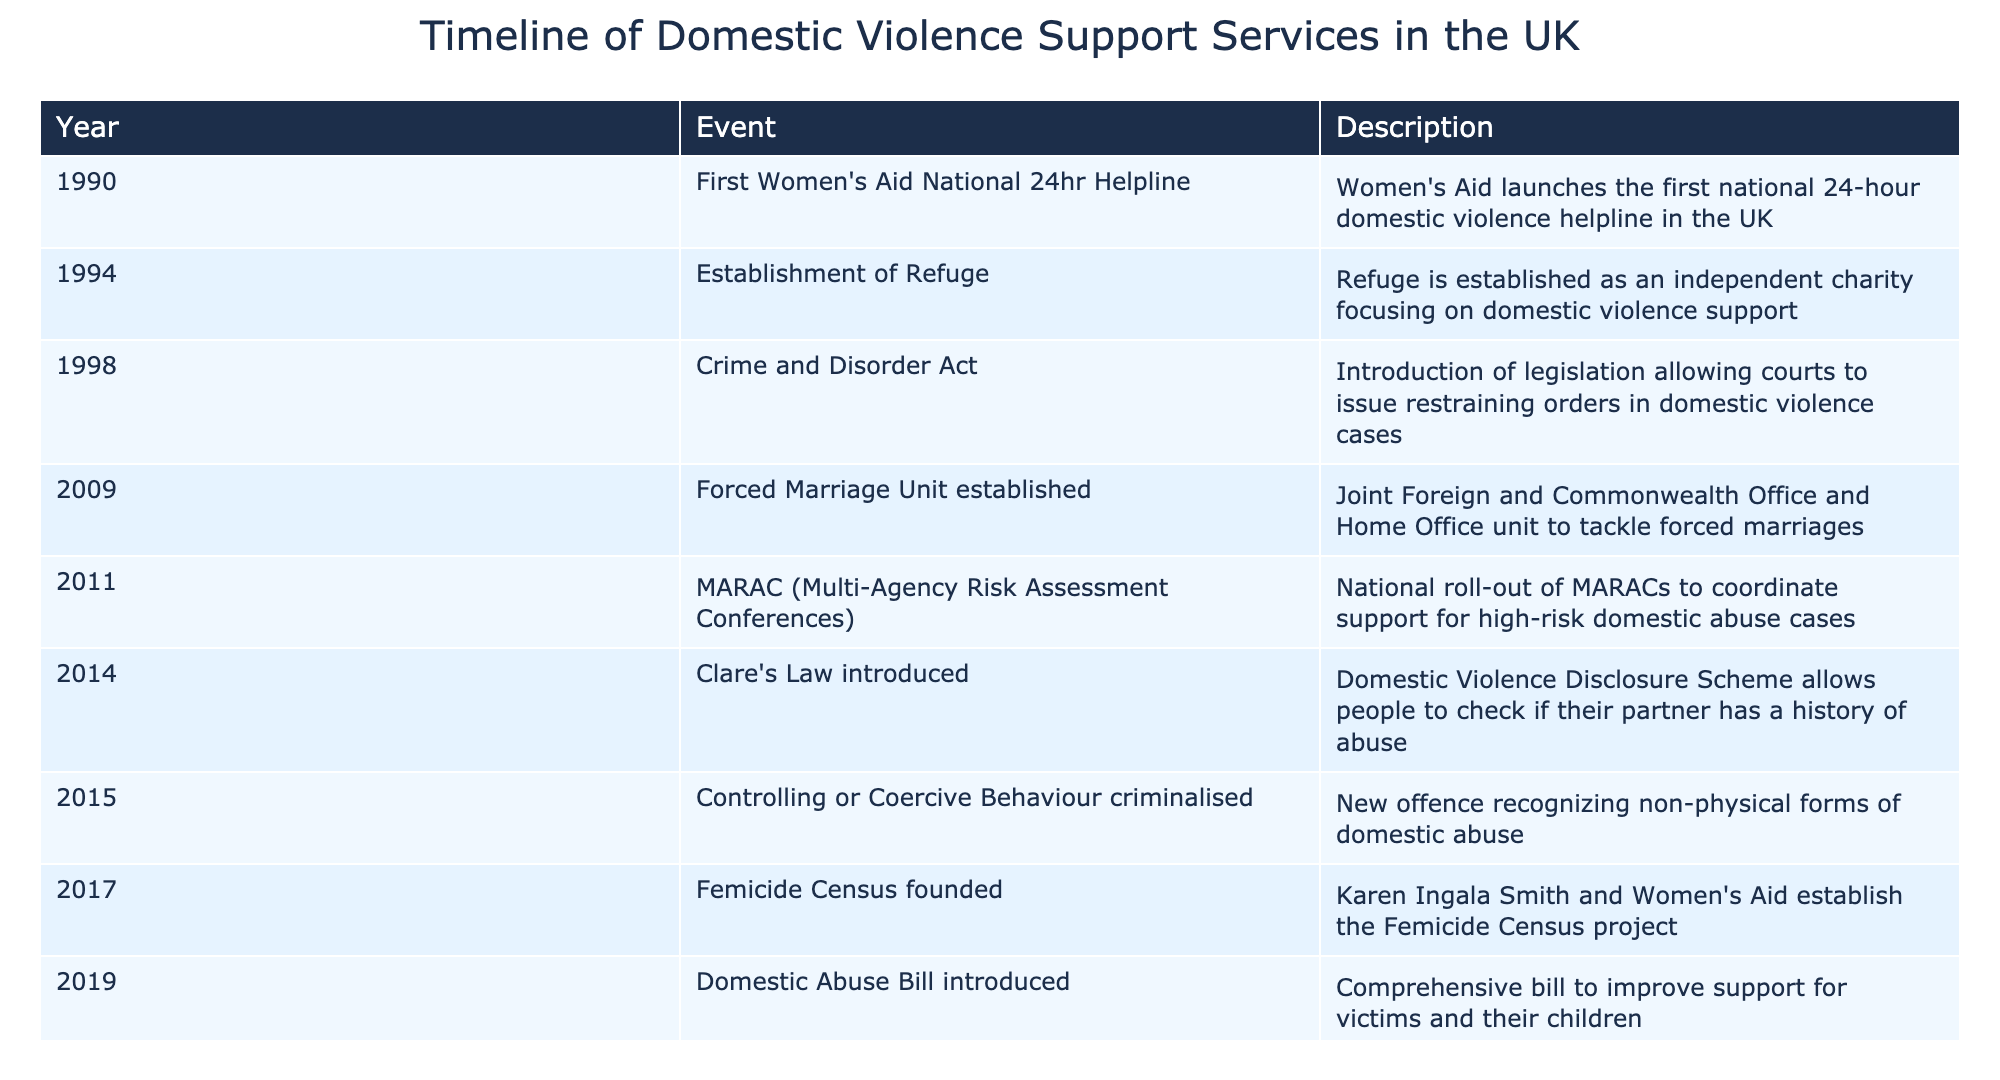What year was the first Women's Aid National 24hr Helpline launched? According to the table, the first Women's Aid National 24hr Helpline was launched in the year 1990.
Answer: 1990 What event marked the establishment of Refuge as an independent charity? The table specifies that Refuge was established in 1994, focusing on domestic violence support.
Answer: Establishment of Refuge In which year was the Crime and Disorder Act introduced? The table lists the Crime and Disorder Act as being introduced in 1998.
Answer: 1998 True or False: The Domestic Abuse Act was passed before the Clare's Law was introduced. The table shows that the Clare's Law was introduced in 2014 and the Domestic Abuse Act was passed in 2021, indicating that the Domestic Abuse Act came after Clare's Law.
Answer: False How many years passed between the launch of the first national helpline and the establishment of Refuge? The first national 24hr helpline was launched in 1990 and Refuge was established in 1994. The difference is 4 years (1994 - 1990 = 4).
Answer: 4 years What is the total number of significant events listed in the table? The table lists 10 events in total related to the evolution of support services for domestic violence victims, from 1990 to 2023.
Answer: 10 events Was the Forced Marriage Unit established before or after the MARAC national rollout? The Forced Marriage Unit was established in 2009 and MARAC was rolled out in 2011, which means the Forced Marriage Unit was established before MARAC.
Answer: Before What significant change occurred in 2015 regarding domestic abuse laws? The table notes that in 2015, controlling or coercive behavior was criminalized, marking a significant shift in the legal framework surrounding domestic abuse.
Answer: Criminalization of controlling or coercive behavior How many years are there between the introduction of the Domestic Abuse Bill and the establishment of the Femicide Census? The Femicide Census was founded in 2017 and the Domestic Abuse Bill was introduced in 2019, which means 2 years passed (2019 - 2017 = 2).
Answer: 2 years 